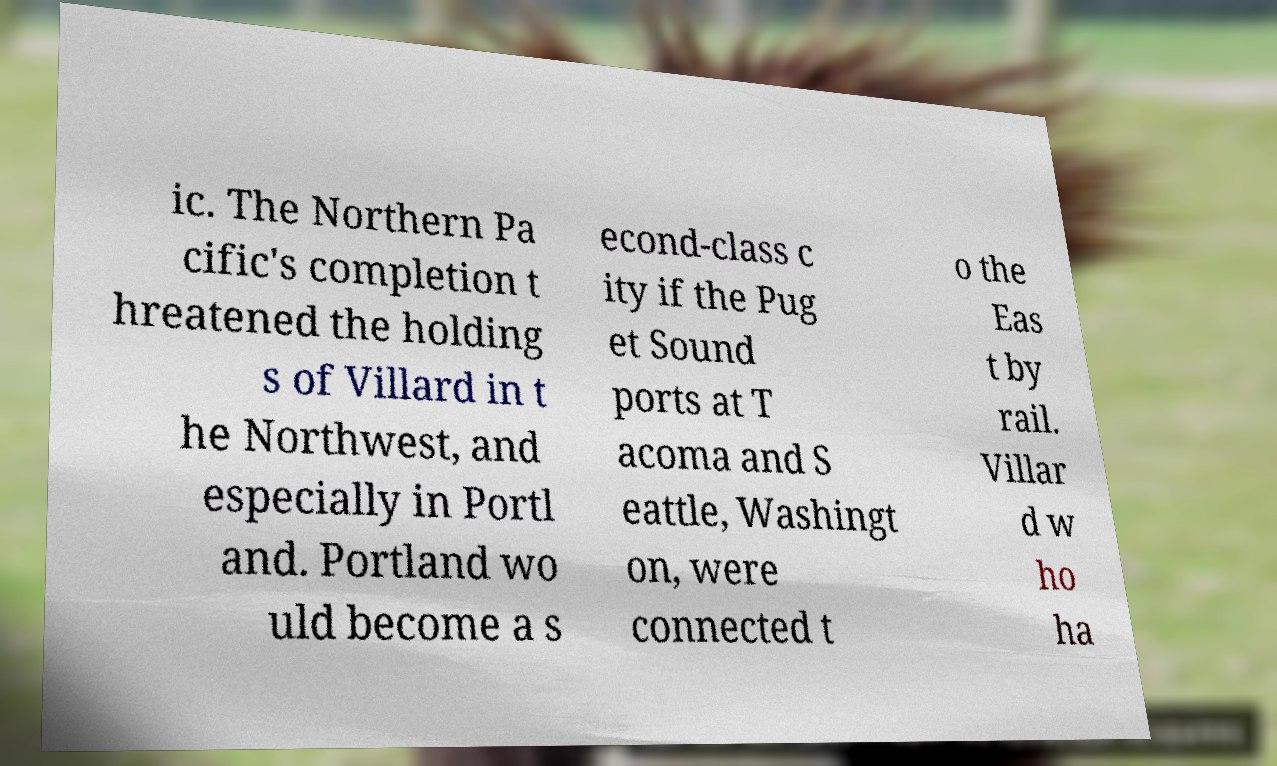I need the written content from this picture converted into text. Can you do that? ic. The Northern Pa cific's completion t hreatened the holding s of Villard in t he Northwest, and especially in Portl and. Portland wo uld become a s econd-class c ity if the Pug et Sound ports at T acoma and S eattle, Washingt on, were connected t o the Eas t by rail. Villar d w ho ha 